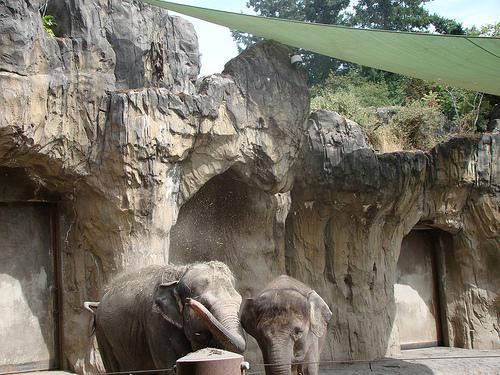Question: what animal is pictured?
Choices:
A. Lion.
B. Giraffe.
C. Tiger.
D. Elephant.
Answer with the letter. Answer: D Question: who took the photo?
Choices:
A. Tourist.
B. Police man.
C. Photographer.
D. Tour guide.
Answer with the letter. Answer: A Question: what color are the elephants?
Choices:
A. Brown.
B. White.
C. Grey.
D. Black.
Answer with the letter. Answer: C Question: how many elephants are there?
Choices:
A. Two.
B. Three.
C. One.
D. Zero.
Answer with the letter. Answer: A Question: when was the photo taken?
Choices:
A. Morning.
B. Afternoon.
C. Dawn.
D. Dusk.
Answer with the letter. Answer: B Question: what is the enclosure made of?
Choices:
A. Fencing.
B. Concrete.
C. Wood.
D. Rock.
Answer with the letter. Answer: D 